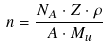Convert formula to latex. <formula><loc_0><loc_0><loc_500><loc_500>n = \frac { N _ { A } \cdot Z \cdot \rho } { A \cdot M _ { u } }</formula> 